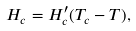Convert formula to latex. <formula><loc_0><loc_0><loc_500><loc_500>H _ { c } = H _ { c } ^ { \prime } ( T _ { c } - T ) ,</formula> 